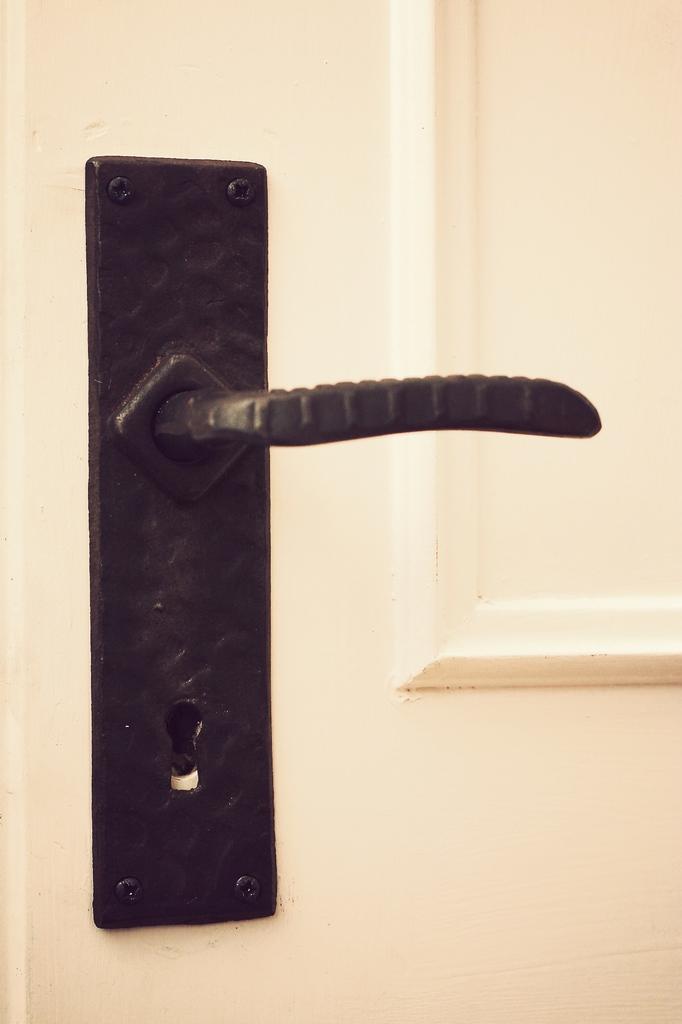Describe this image in one or two sentences. In this image we can see a handle on a door. 